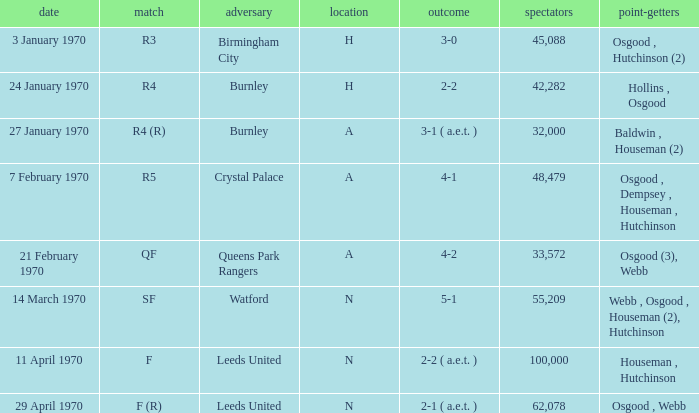What round was the match with a score of 5-1 at n location? SF. 